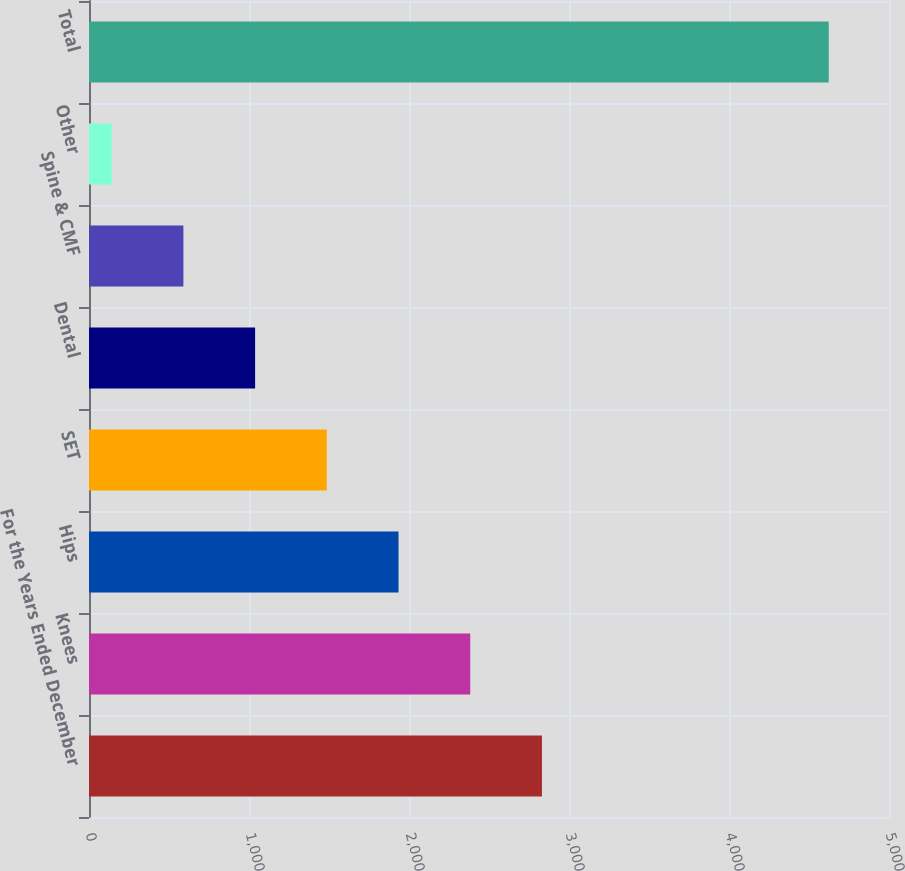Convert chart to OTSL. <chart><loc_0><loc_0><loc_500><loc_500><bar_chart><fcel>For the Years Ended December<fcel>Knees<fcel>Hips<fcel>SET<fcel>Dental<fcel>Spine & CMF<fcel>Other<fcel>Total<nl><fcel>2830.8<fcel>2382.65<fcel>1934.5<fcel>1486.35<fcel>1038.2<fcel>590.05<fcel>141.9<fcel>4623.4<nl></chart> 